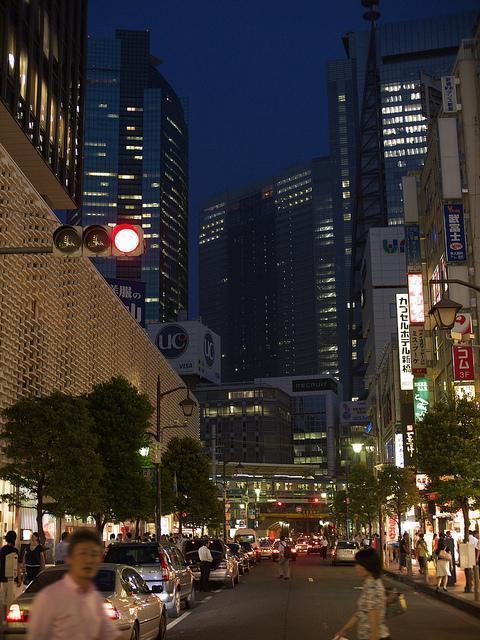How many cars are visible?
Give a very brief answer. 2. How many people can you see?
Give a very brief answer. 2. How many benches are on the left of the room?
Give a very brief answer. 0. 